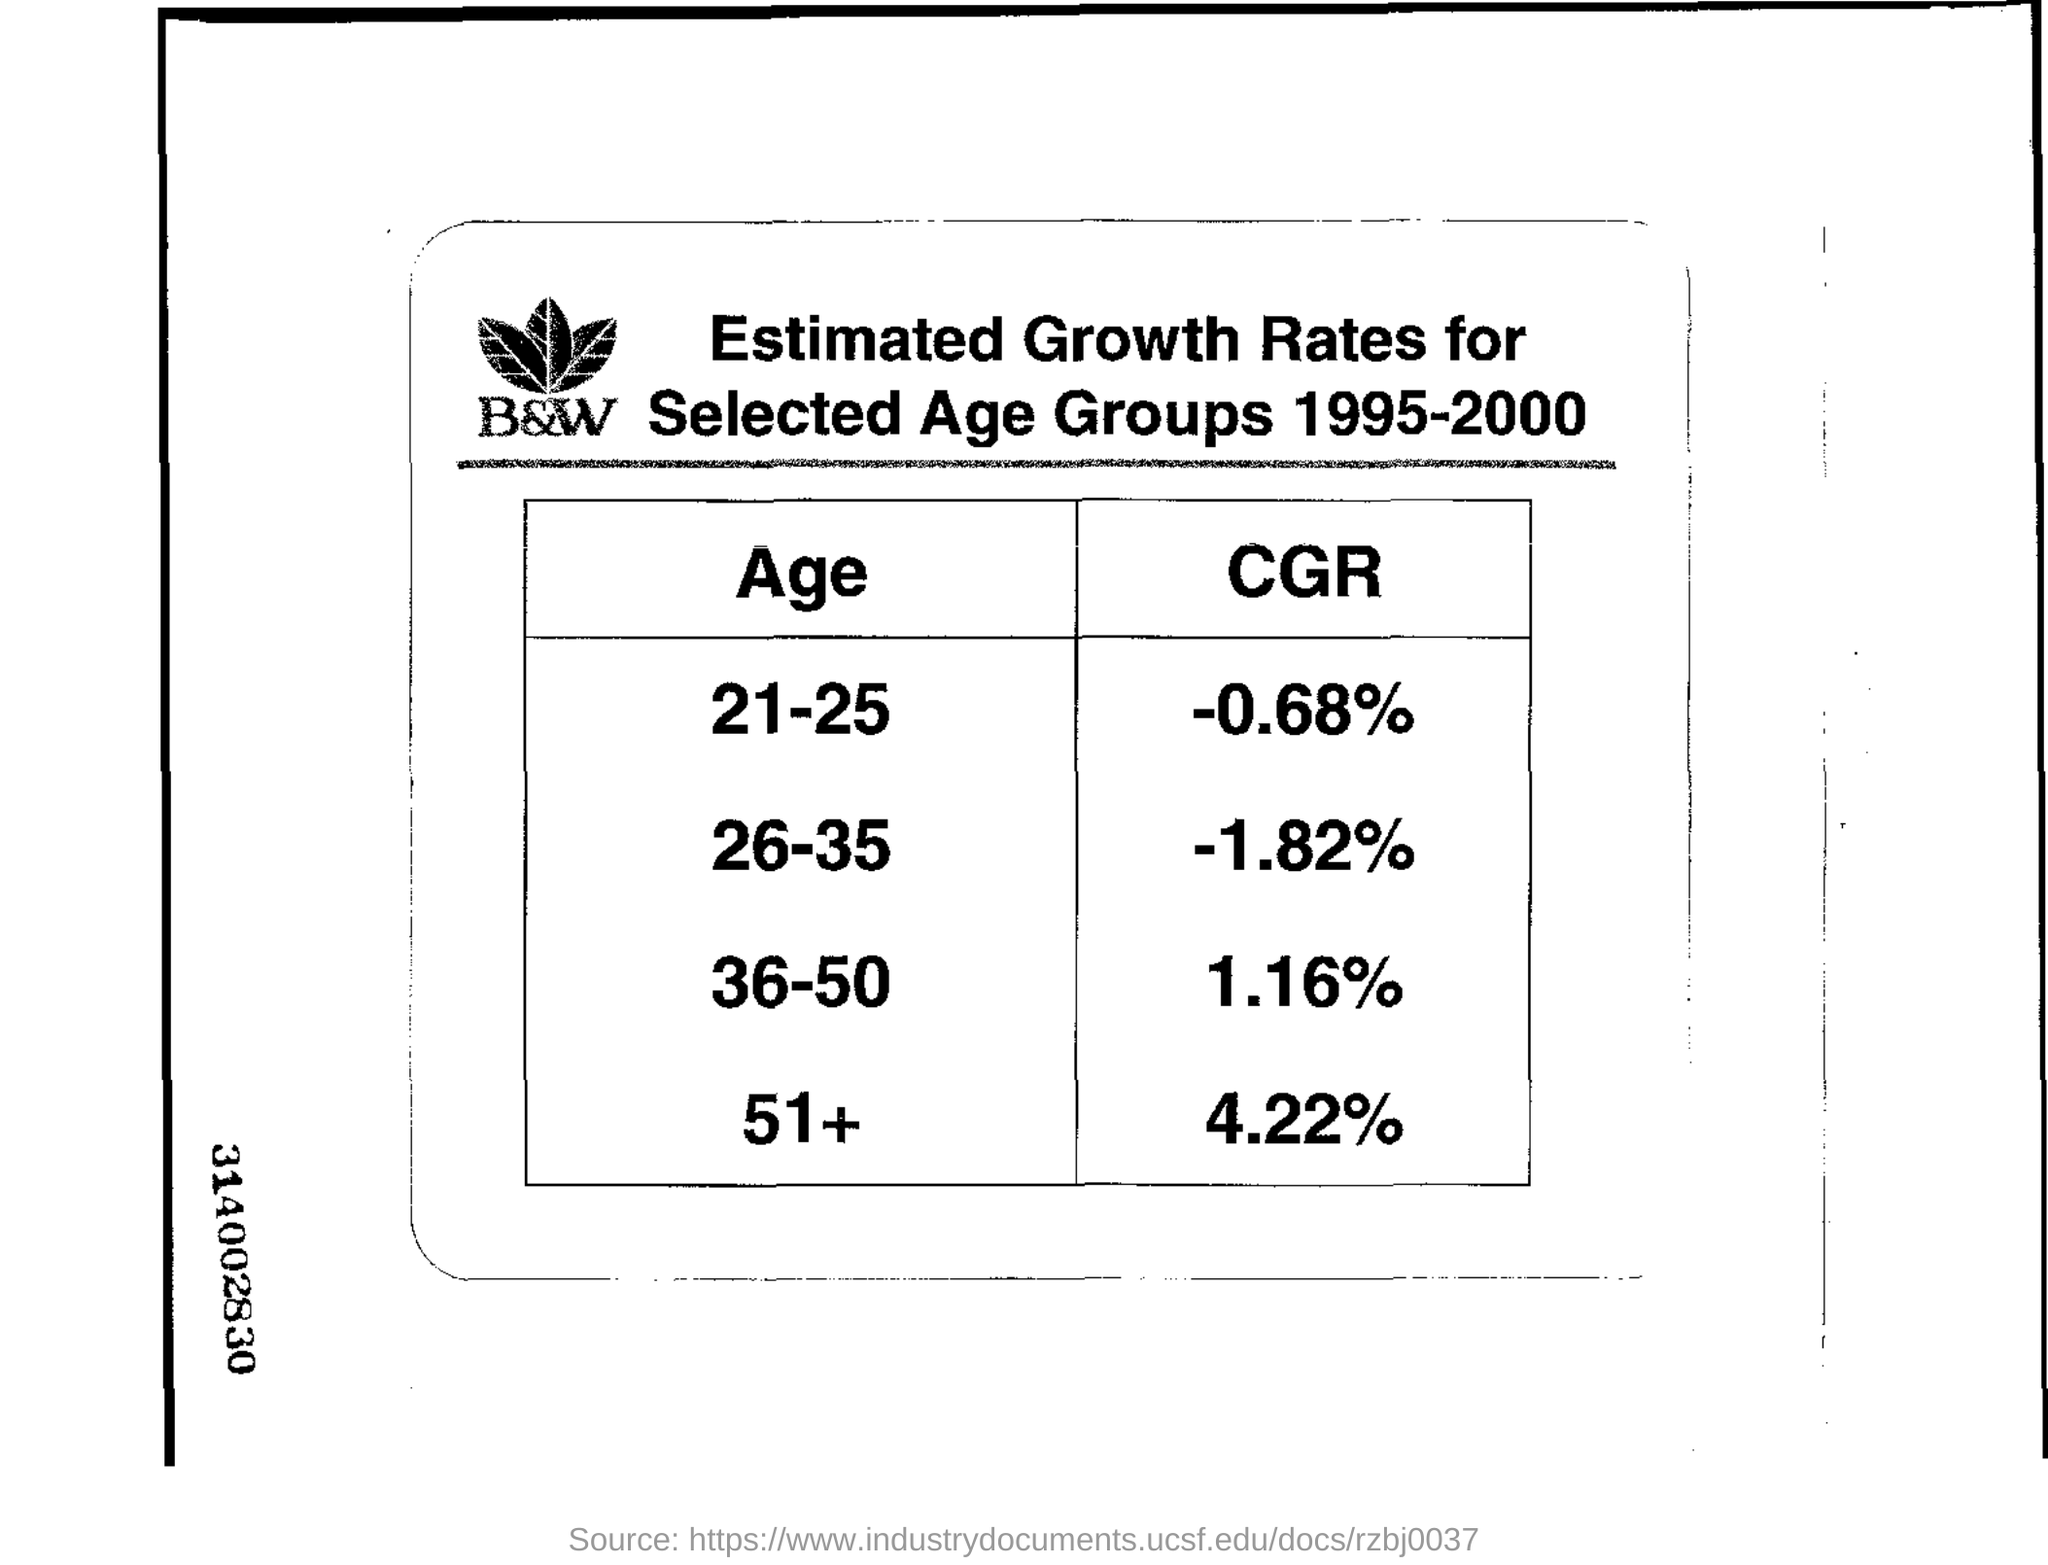Specify some key components in this picture. The 26-35 age group is estimated to have the lowest growth rate or CGR. The current age group of 21-25 has a negative consumer goods and services (CG&S) growth rate of -0.68%. The 51+ age group is estimated to have the highest growth rate or CGR. The estimated growth rates were taken between the years 1995 and 2000. 